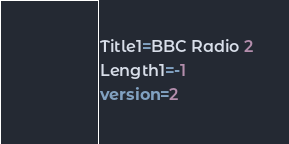Convert code to text. <code><loc_0><loc_0><loc_500><loc_500><_SQL_>Title1=BBC Radio 2
Length1=-1
version=2
</code> 